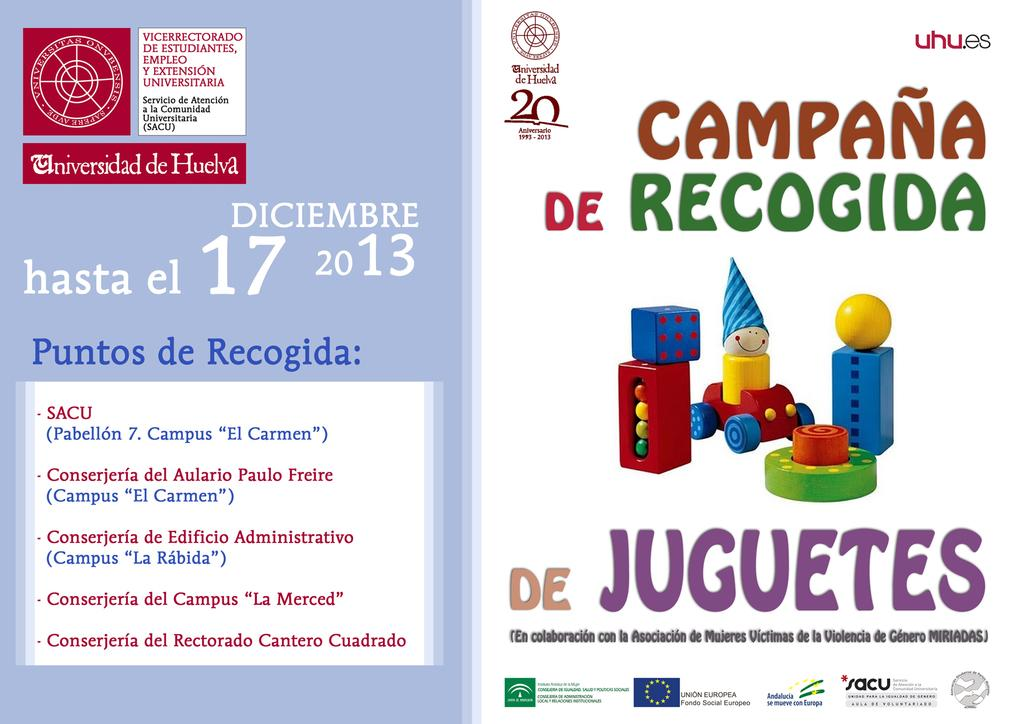What language is used in the text visible in the image? The image contains Spanish text. What can be seen in the middle of the image? There are toy pictures in the middle of the image. Can you describe the girl playing with the toys in the image? There is no girl present in the image; it only contains toy pictures and Spanish text. What type of destruction can be seen in the image? There is no destruction present in the image; it features toy pictures and Spanish text. 